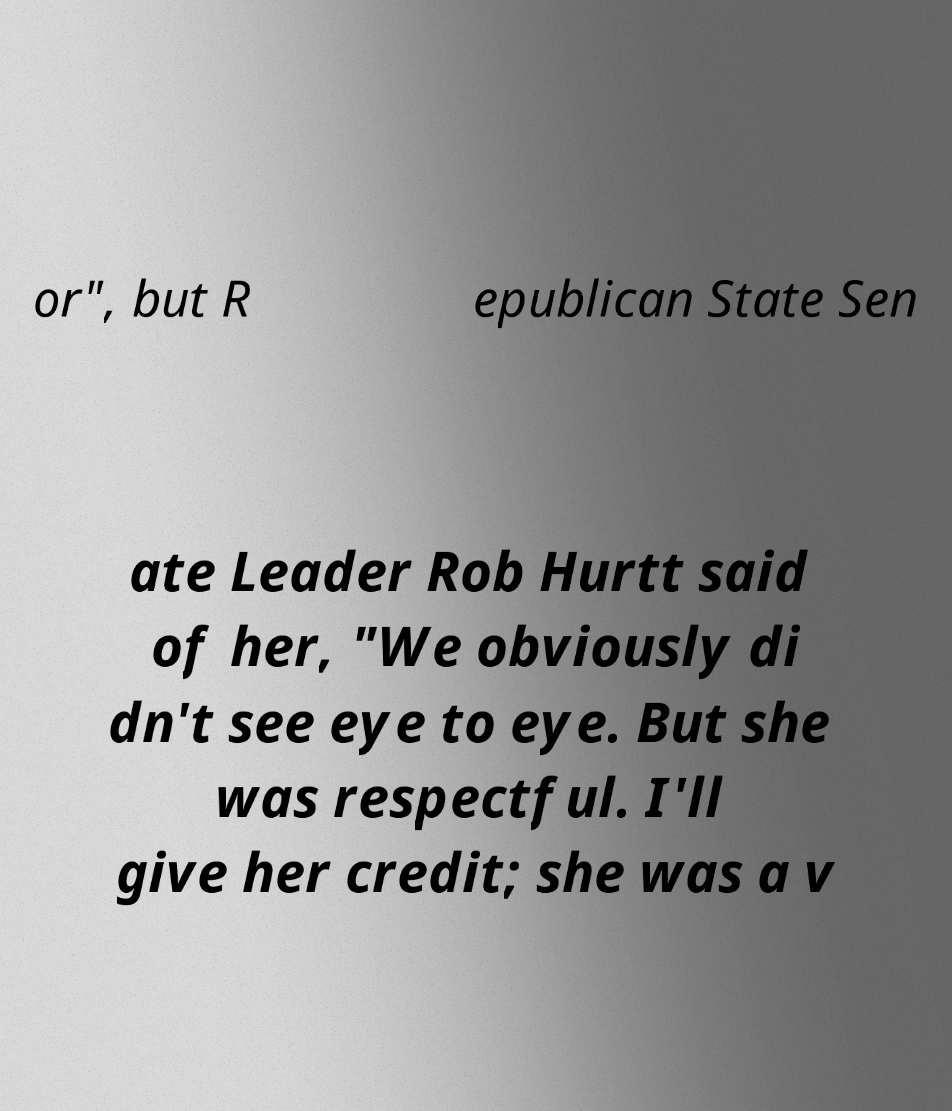Could you extract and type out the text from this image? or", but R epublican State Sen ate Leader Rob Hurtt said of her, "We obviously di dn't see eye to eye. But she was respectful. I'll give her credit; she was a v 